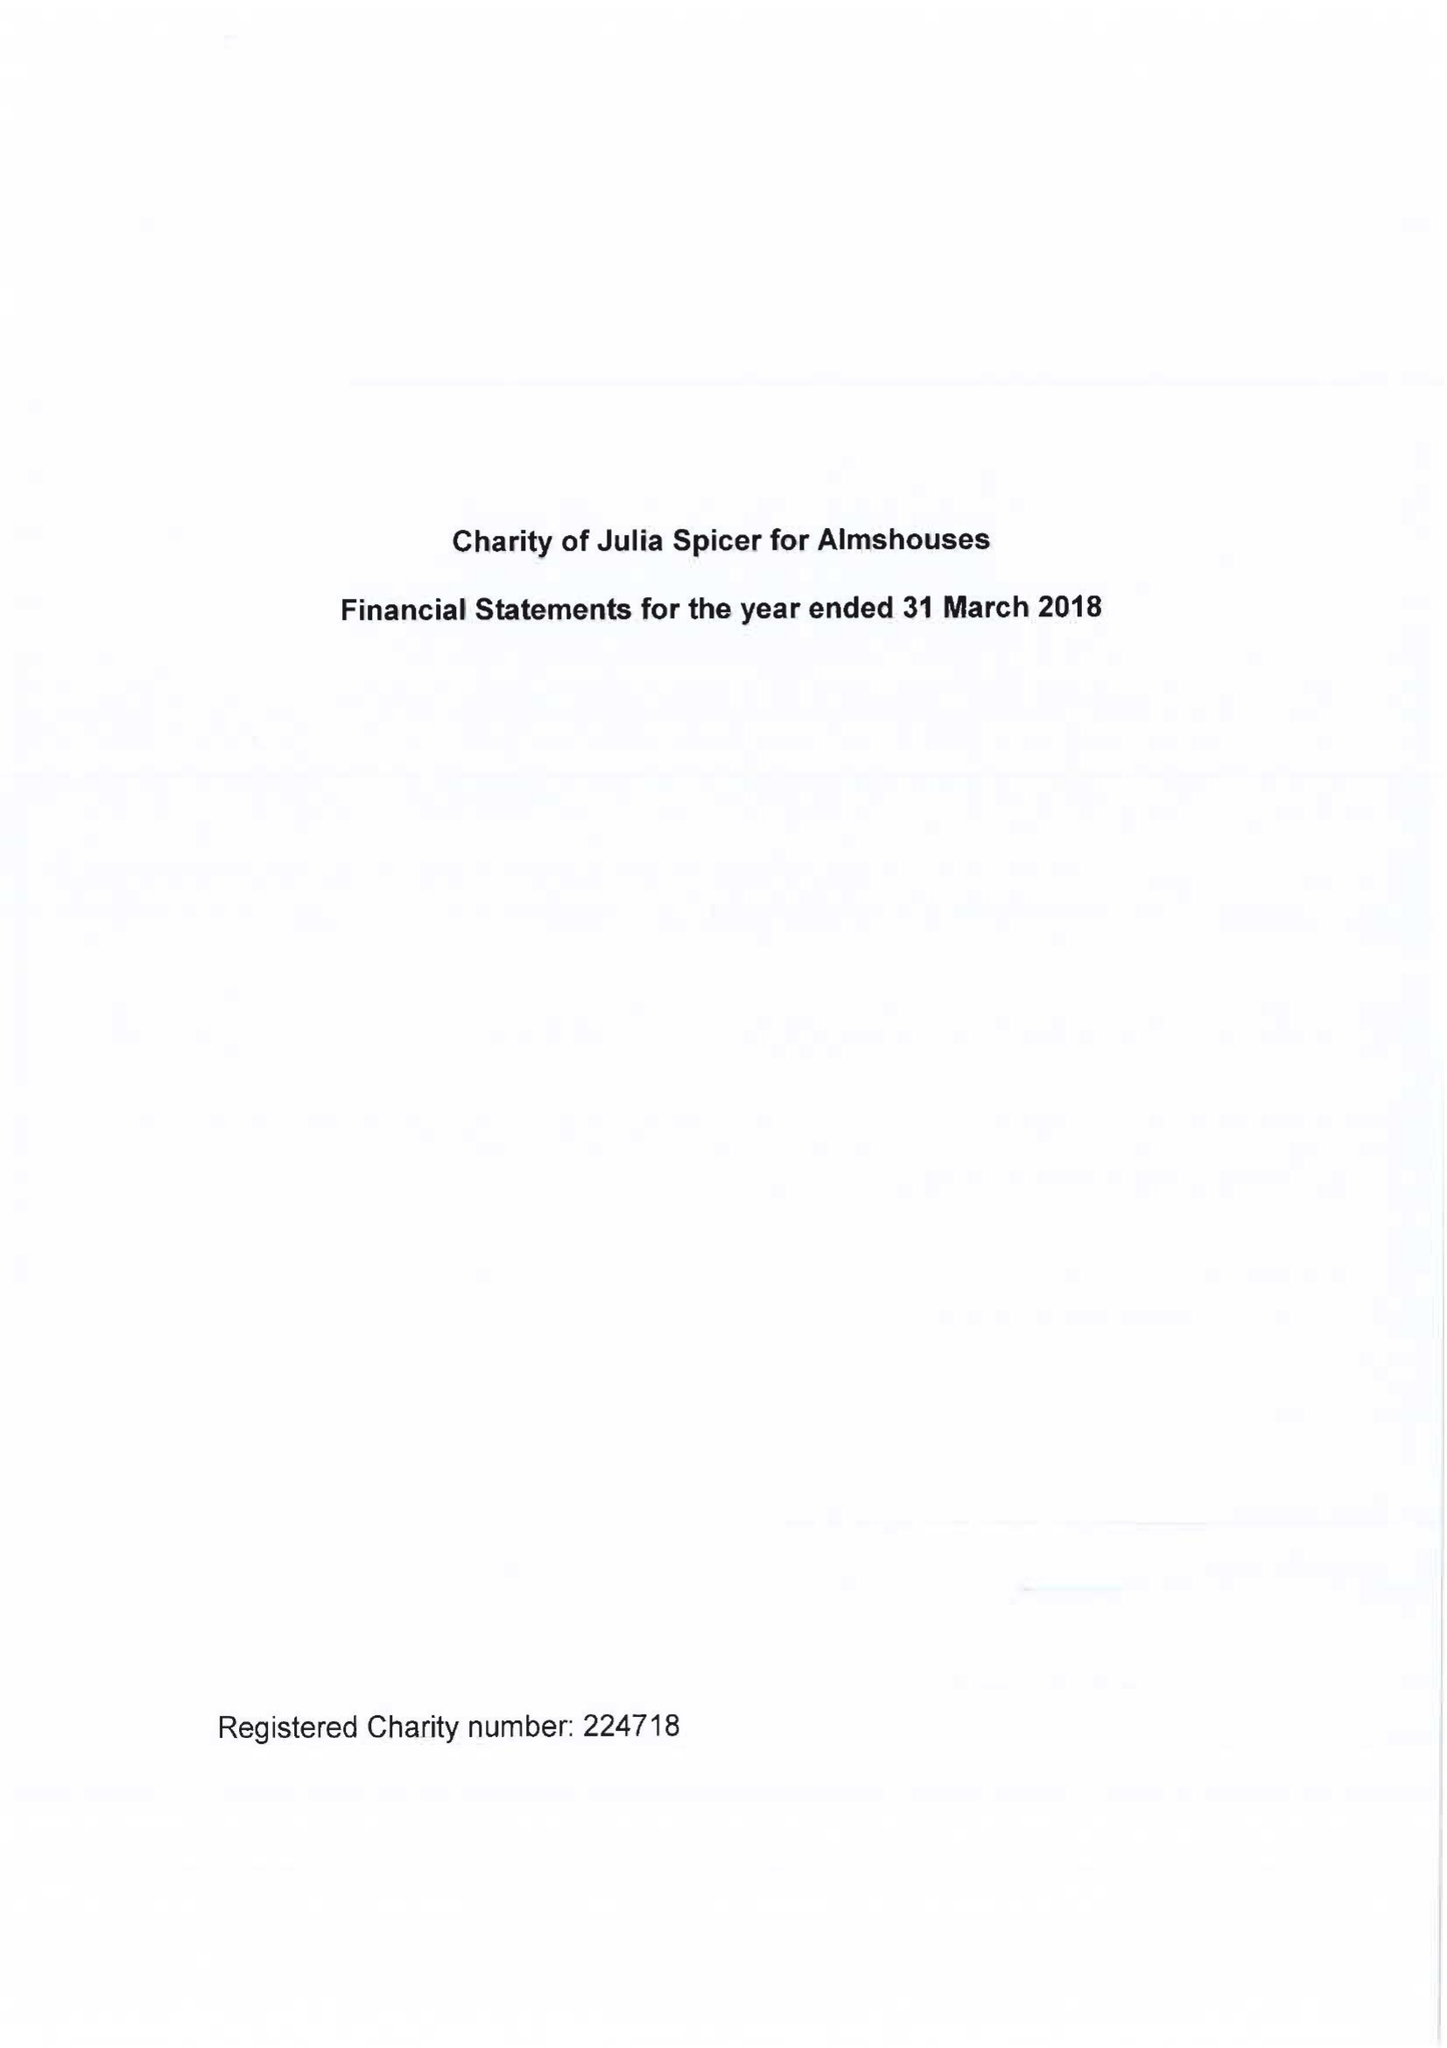What is the value for the address__street_line?
Answer the question using a single word or phrase. 125 HIGH STREET 